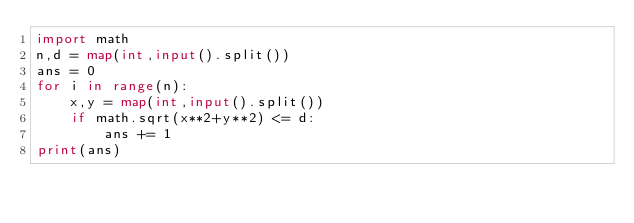<code> <loc_0><loc_0><loc_500><loc_500><_Python_>import math
n,d = map(int,input().split())
ans = 0
for i in range(n):
    x,y = map(int,input().split())
    if math.sqrt(x**2+y**2) <= d:
        ans += 1
print(ans)
</code> 